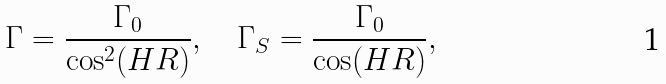<formula> <loc_0><loc_0><loc_500><loc_500>\Gamma = \frac { \Gamma _ { 0 } } { \cos ^ { 2 } ( H R ) } , \quad \Gamma _ { S } = \frac { \Gamma _ { 0 } } { \cos ( H R ) } ,</formula> 